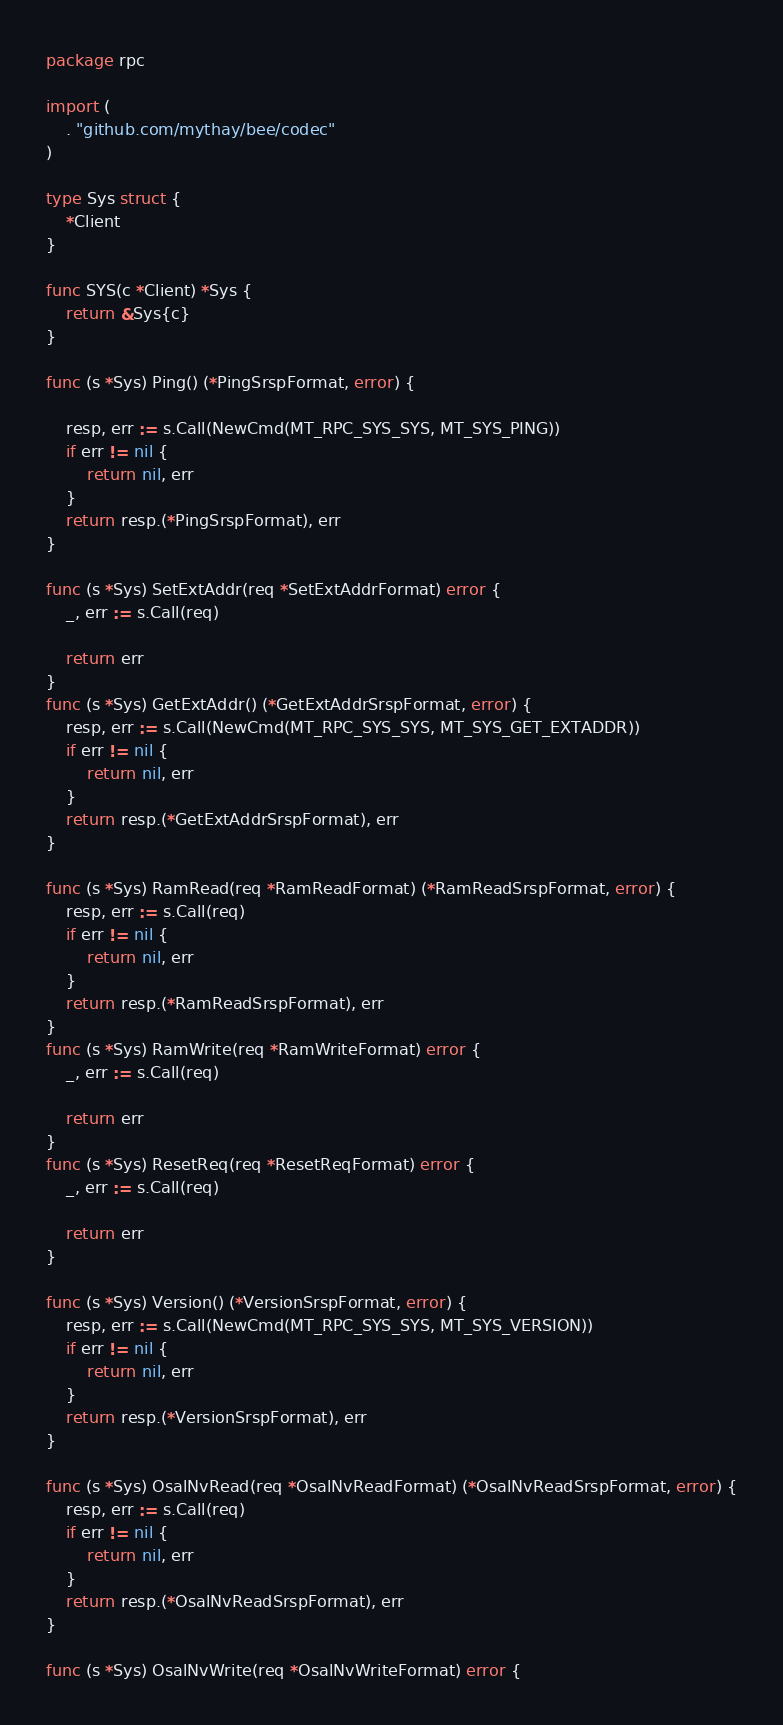Convert code to text. <code><loc_0><loc_0><loc_500><loc_500><_Go_>package rpc

import (
	. "github.com/mythay/bee/codec"
)

type Sys struct {
	*Client
}

func SYS(c *Client) *Sys {
	return &Sys{c}
}

func (s *Sys) Ping() (*PingSrspFormat, error) {

	resp, err := s.Call(NewCmd(MT_RPC_SYS_SYS, MT_SYS_PING))
	if err != nil {
		return nil, err
	}
	return resp.(*PingSrspFormat), err
}

func (s *Sys) SetExtAddr(req *SetExtAddrFormat) error {
	_, err := s.Call(req)

	return err
}
func (s *Sys) GetExtAddr() (*GetExtAddrSrspFormat, error) {
	resp, err := s.Call(NewCmd(MT_RPC_SYS_SYS, MT_SYS_GET_EXTADDR))
	if err != nil {
		return nil, err
	}
	return resp.(*GetExtAddrSrspFormat), err
}

func (s *Sys) RamRead(req *RamReadFormat) (*RamReadSrspFormat, error) {
	resp, err := s.Call(req)
	if err != nil {
		return nil, err
	}
	return resp.(*RamReadSrspFormat), err
}
func (s *Sys) RamWrite(req *RamWriteFormat) error {
	_, err := s.Call(req)

	return err
}
func (s *Sys) ResetReq(req *ResetReqFormat) error {
	_, err := s.Call(req)

	return err
}

func (s *Sys) Version() (*VersionSrspFormat, error) {
	resp, err := s.Call(NewCmd(MT_RPC_SYS_SYS, MT_SYS_VERSION))
	if err != nil {
		return nil, err
	}
	return resp.(*VersionSrspFormat), err
}

func (s *Sys) OsalNvRead(req *OsalNvReadFormat) (*OsalNvReadSrspFormat, error) {
	resp, err := s.Call(req)
	if err != nil {
		return nil, err
	}
	return resp.(*OsalNvReadSrspFormat), err
}

func (s *Sys) OsalNvWrite(req *OsalNvWriteFormat) error {</code> 